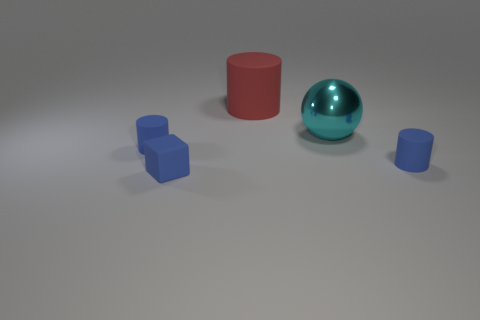Subtract all blue cylinders. How many cylinders are left? 1 Subtract all red cylinders. How many cylinders are left? 2 Add 4 blocks. How many objects exist? 9 Subtract all spheres. How many objects are left? 4 Subtract 1 blocks. How many blocks are left? 0 Subtract 0 yellow spheres. How many objects are left? 5 Subtract all purple blocks. Subtract all cyan cylinders. How many blocks are left? 1 Subtract all red cubes. How many blue cylinders are left? 2 Subtract all large cylinders. Subtract all blue blocks. How many objects are left? 3 Add 1 blue cubes. How many blue cubes are left? 2 